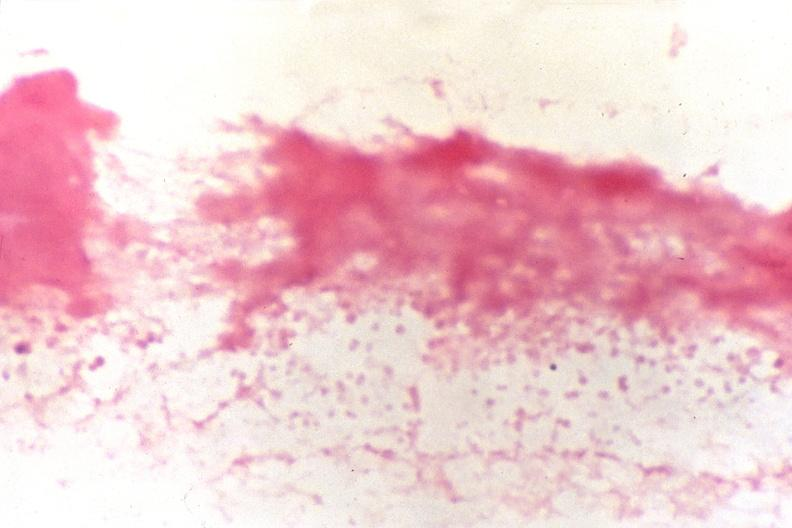s cerebrospinal fluid, smear showing gram negative cocci, neisseria meningitidis, gram stain present?
Answer the question using a single word or phrase. Yes 